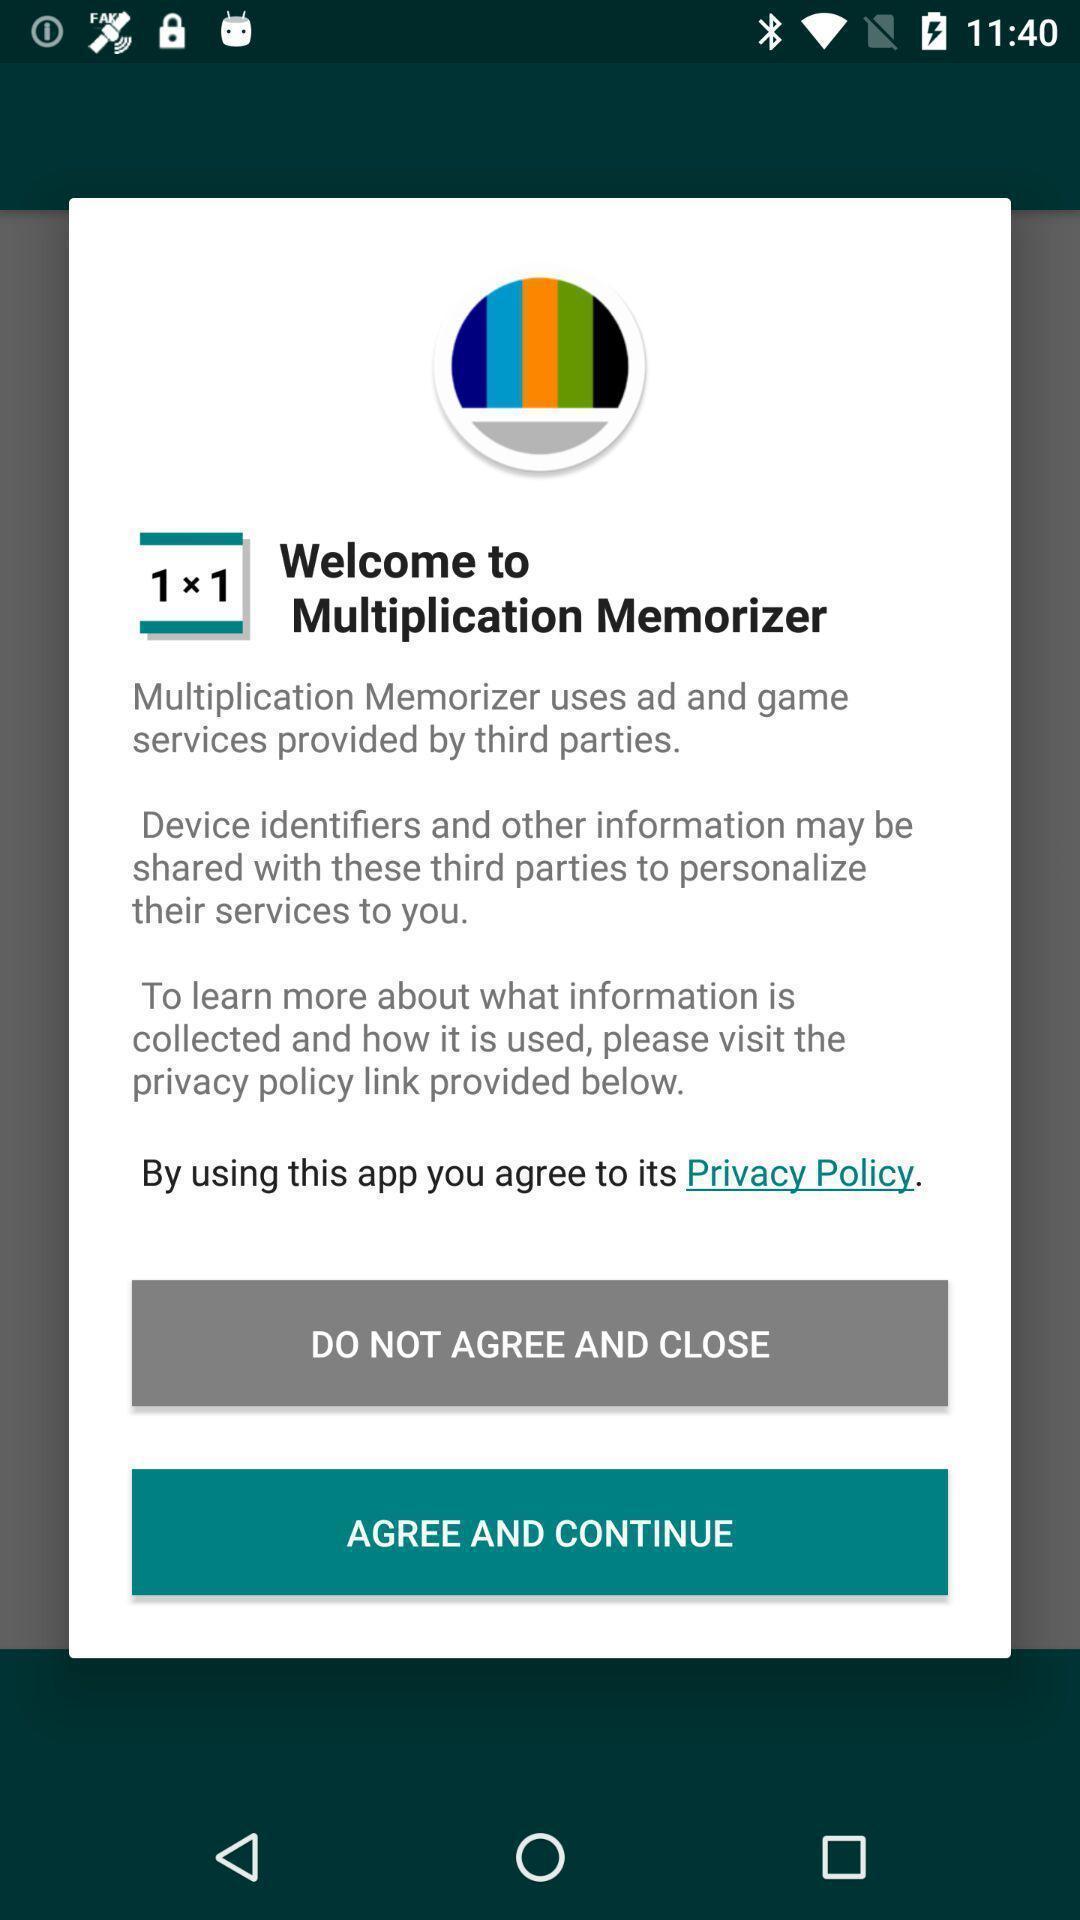What details can you identify in this image? Welcome pop up box in a memorizing app. 